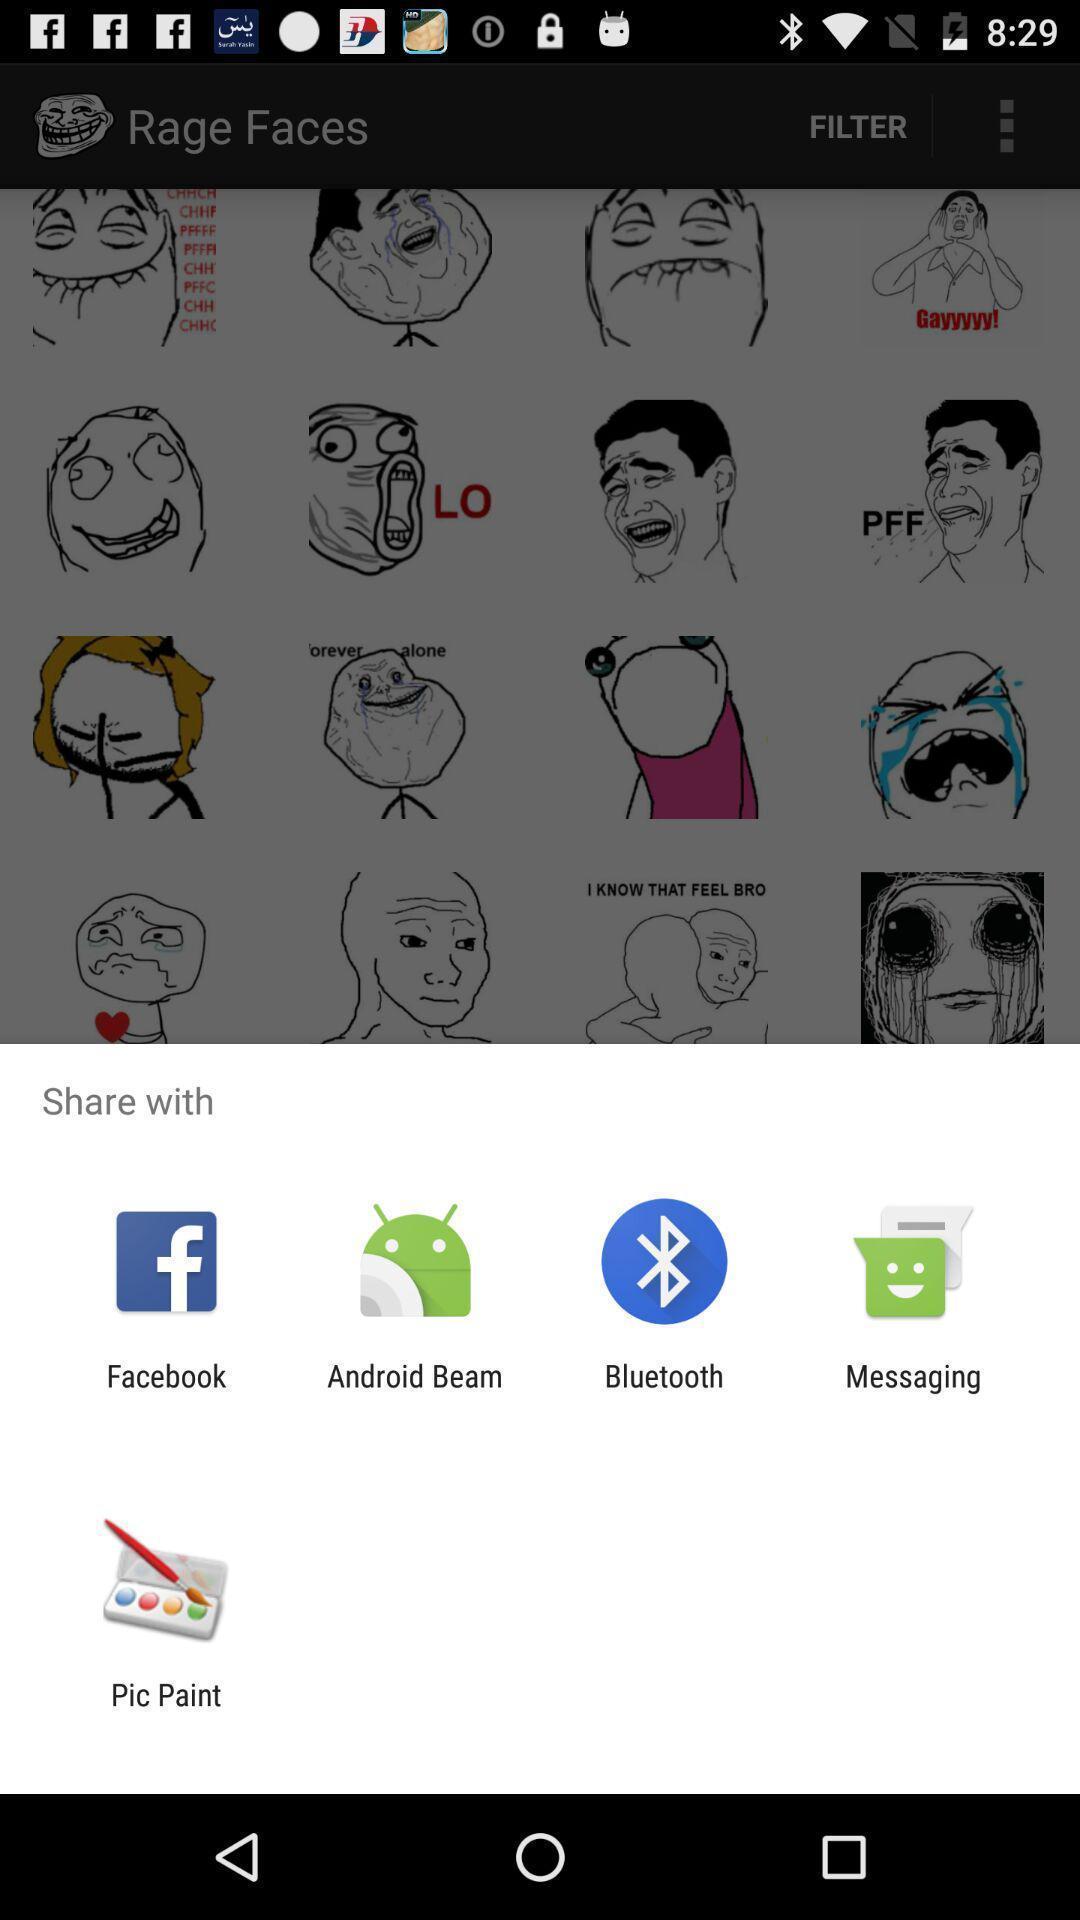Summarize the main components in this picture. Popup to share in the meme faces app. 